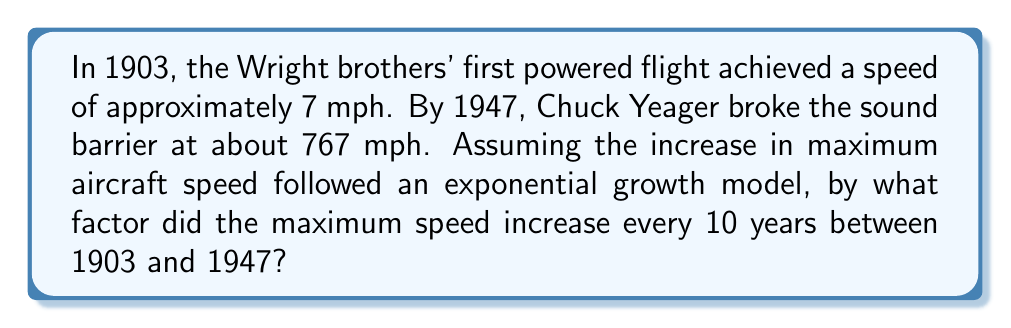Teach me how to tackle this problem. Let's approach this step-by-step:

1) We'll use the exponential growth formula: $A = P(1 + r)^t$
   Where A is the final amount, P is the initial amount, r is the growth rate, and t is the time.

2) We have:
   P = 7 mph (initial speed in 1903)
   A = 767 mph (final speed in 1947)
   t = 44 years (time between 1903 and 1947)

3) Let x be the factor of increase every 10 years. Then for 44 years, the factor would be $x^{4.4}$

4) We can write the equation:
   $767 = 7(x^{4.4})$

5) Dividing both sides by 7:
   $109.5714 = x^{4.4}$

6) Taking the 4.4th root of both sides:
   $x = (109.5714)^{\frac{1}{4.4}} \approx 2.8228$

7) This means the speed increased by a factor of about 2.8228 every 10 years.
Answer: $2.8228$ 